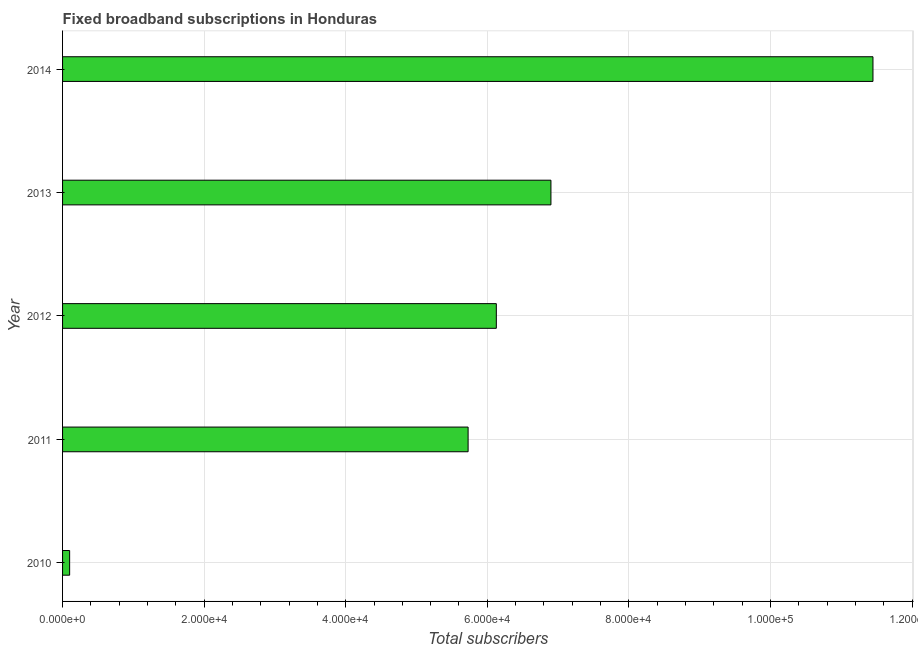Does the graph contain grids?
Provide a succinct answer. Yes. What is the title of the graph?
Provide a short and direct response. Fixed broadband subscriptions in Honduras. What is the label or title of the X-axis?
Keep it short and to the point. Total subscribers. What is the total number of fixed broadband subscriptions in 2012?
Offer a very short reply. 6.13e+04. Across all years, what is the maximum total number of fixed broadband subscriptions?
Offer a terse response. 1.14e+05. In which year was the total number of fixed broadband subscriptions maximum?
Give a very brief answer. 2014. In which year was the total number of fixed broadband subscriptions minimum?
Your answer should be very brief. 2010. What is the sum of the total number of fixed broadband subscriptions?
Your answer should be very brief. 3.03e+05. What is the difference between the total number of fixed broadband subscriptions in 2012 and 2014?
Your response must be concise. -5.32e+04. What is the average total number of fixed broadband subscriptions per year?
Your answer should be very brief. 6.06e+04. What is the median total number of fixed broadband subscriptions?
Keep it short and to the point. 6.13e+04. What is the ratio of the total number of fixed broadband subscriptions in 2011 to that in 2014?
Offer a terse response. 0.5. Is the total number of fixed broadband subscriptions in 2011 less than that in 2012?
Give a very brief answer. Yes. Is the difference between the total number of fixed broadband subscriptions in 2010 and 2012 greater than the difference between any two years?
Offer a terse response. No. What is the difference between the highest and the second highest total number of fixed broadband subscriptions?
Your answer should be compact. 4.55e+04. Is the sum of the total number of fixed broadband subscriptions in 2012 and 2013 greater than the maximum total number of fixed broadband subscriptions across all years?
Provide a succinct answer. Yes. What is the difference between the highest and the lowest total number of fixed broadband subscriptions?
Give a very brief answer. 1.13e+05. In how many years, is the total number of fixed broadband subscriptions greater than the average total number of fixed broadband subscriptions taken over all years?
Keep it short and to the point. 3. What is the difference between two consecutive major ticks on the X-axis?
Offer a terse response. 2.00e+04. Are the values on the major ticks of X-axis written in scientific E-notation?
Provide a short and direct response. Yes. What is the Total subscribers in 2011?
Give a very brief answer. 5.73e+04. What is the Total subscribers in 2012?
Offer a terse response. 6.13e+04. What is the Total subscribers of 2013?
Provide a short and direct response. 6.90e+04. What is the Total subscribers in 2014?
Provide a succinct answer. 1.14e+05. What is the difference between the Total subscribers in 2010 and 2011?
Provide a succinct answer. -5.63e+04. What is the difference between the Total subscribers in 2010 and 2012?
Offer a very short reply. -6.03e+04. What is the difference between the Total subscribers in 2010 and 2013?
Your answer should be very brief. -6.80e+04. What is the difference between the Total subscribers in 2010 and 2014?
Your response must be concise. -1.13e+05. What is the difference between the Total subscribers in 2011 and 2012?
Give a very brief answer. -3987. What is the difference between the Total subscribers in 2011 and 2013?
Your answer should be very brief. -1.17e+04. What is the difference between the Total subscribers in 2011 and 2014?
Make the answer very short. -5.72e+04. What is the difference between the Total subscribers in 2012 and 2013?
Give a very brief answer. -7714. What is the difference between the Total subscribers in 2012 and 2014?
Keep it short and to the point. -5.32e+04. What is the difference between the Total subscribers in 2013 and 2014?
Make the answer very short. -4.55e+04. What is the ratio of the Total subscribers in 2010 to that in 2011?
Provide a succinct answer. 0.02. What is the ratio of the Total subscribers in 2010 to that in 2012?
Offer a very short reply. 0.02. What is the ratio of the Total subscribers in 2010 to that in 2013?
Provide a succinct answer. 0.01. What is the ratio of the Total subscribers in 2010 to that in 2014?
Your answer should be very brief. 0.01. What is the ratio of the Total subscribers in 2011 to that in 2012?
Make the answer very short. 0.94. What is the ratio of the Total subscribers in 2011 to that in 2013?
Offer a terse response. 0.83. What is the ratio of the Total subscribers in 2012 to that in 2013?
Your response must be concise. 0.89. What is the ratio of the Total subscribers in 2012 to that in 2014?
Ensure brevity in your answer.  0.54. What is the ratio of the Total subscribers in 2013 to that in 2014?
Ensure brevity in your answer.  0.6. 